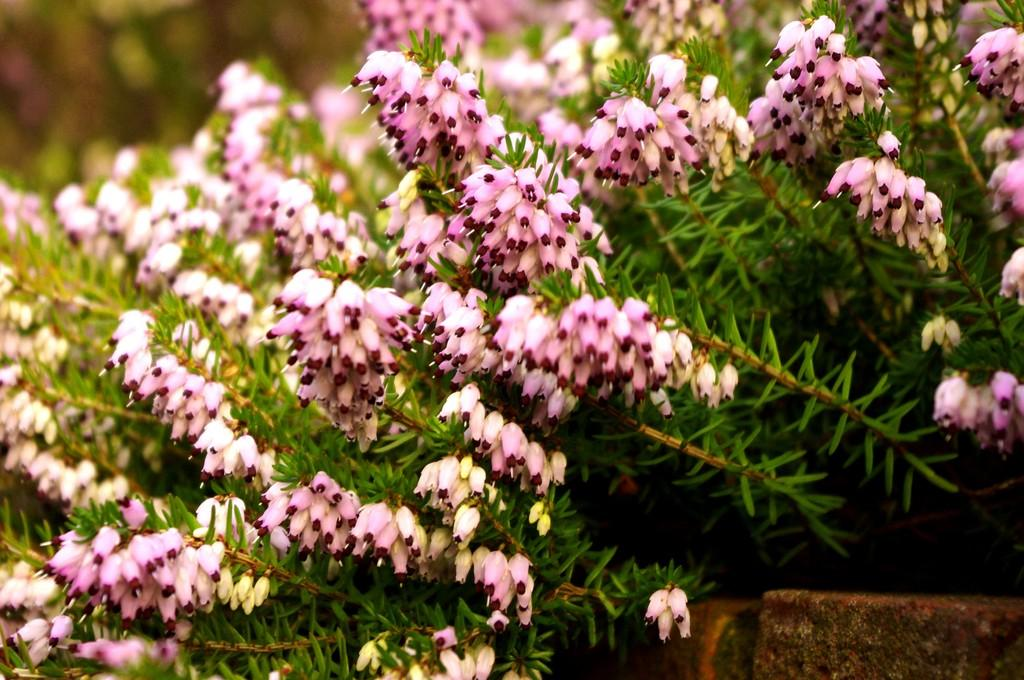What colors are the flowers on the plants in the image? The flowers on the plants are light pink and yellow. Can you describe the quality of the image? The image is blurry at the back. What is located at the bottom right of the image? There is a wall at the bottom right of the image. How many pigs are standing on the wall in the image? There are no pigs present in the image; it features flowers on plants and a wall at the bottom right. 